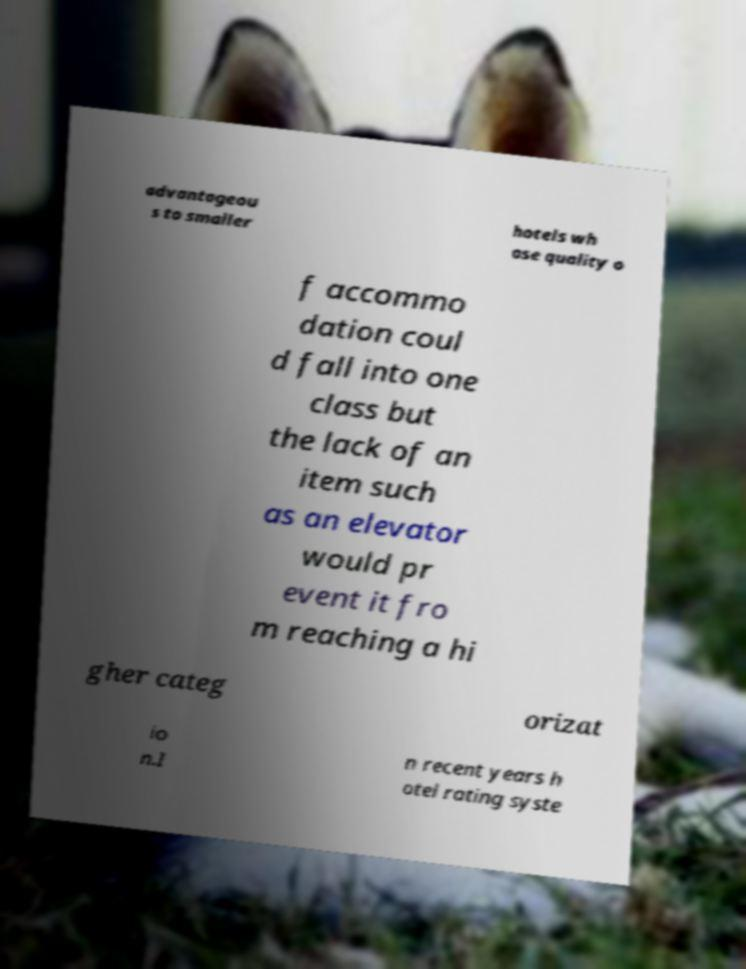For documentation purposes, I need the text within this image transcribed. Could you provide that? advantageou s to smaller hotels wh ose quality o f accommo dation coul d fall into one class but the lack of an item such as an elevator would pr event it fro m reaching a hi gher categ orizat io n.I n recent years h otel rating syste 